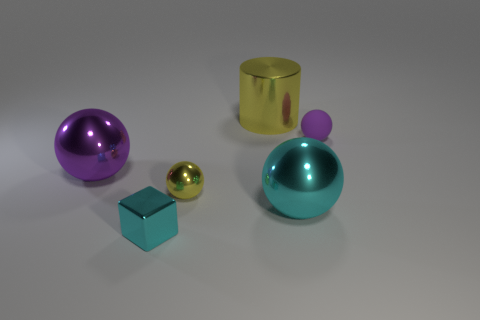How would you describe the arrangement of the objects? The arrangement of the objects seems intentional and artistic, possibly designed to convey balance and proportion. The objects are spaced out evenly and placed in a loose diagonal line that draws the viewer's eye across the image. This deliberate spacing allows each object to stand out individually while maintaining a coherent overall composition. 